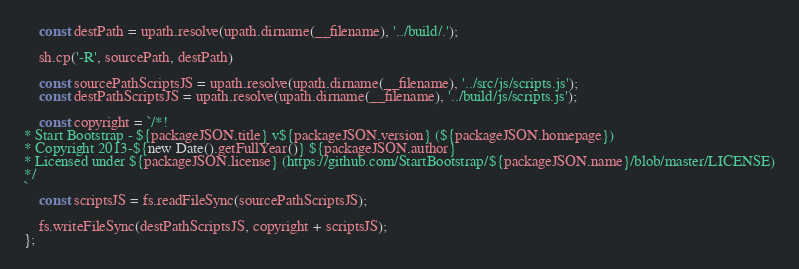Convert code to text. <code><loc_0><loc_0><loc_500><loc_500><_JavaScript_>    const destPath = upath.resolve(upath.dirname(__filename), '../build/.');
    
    sh.cp('-R', sourcePath, destPath)

    const sourcePathScriptsJS = upath.resolve(upath.dirname(__filename), '../src/js/scripts.js');
    const destPathScriptsJS = upath.resolve(upath.dirname(__filename), '../build/js/scripts.js');
    
    const copyright = `/*!
* Start Bootstrap - ${packageJSON.title} v${packageJSON.version} (${packageJSON.homepage})
* Copyright 2013-${new Date().getFullYear()} ${packageJSON.author}
* Licensed under ${packageJSON.license} (https://github.com/StartBootstrap/${packageJSON.name}/blob/master/LICENSE)
*/
`
    const scriptsJS = fs.readFileSync(sourcePathScriptsJS);
    
    fs.writeFileSync(destPathScriptsJS, copyright + scriptsJS);
};</code> 